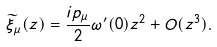<formula> <loc_0><loc_0><loc_500><loc_500>\widetilde { \xi } _ { \mu } ( z ) = \frac { i p _ { \mu } } { 2 } \omega ^ { \prime } ( 0 ) z ^ { 2 } + O ( z ^ { 3 } ) .</formula> 